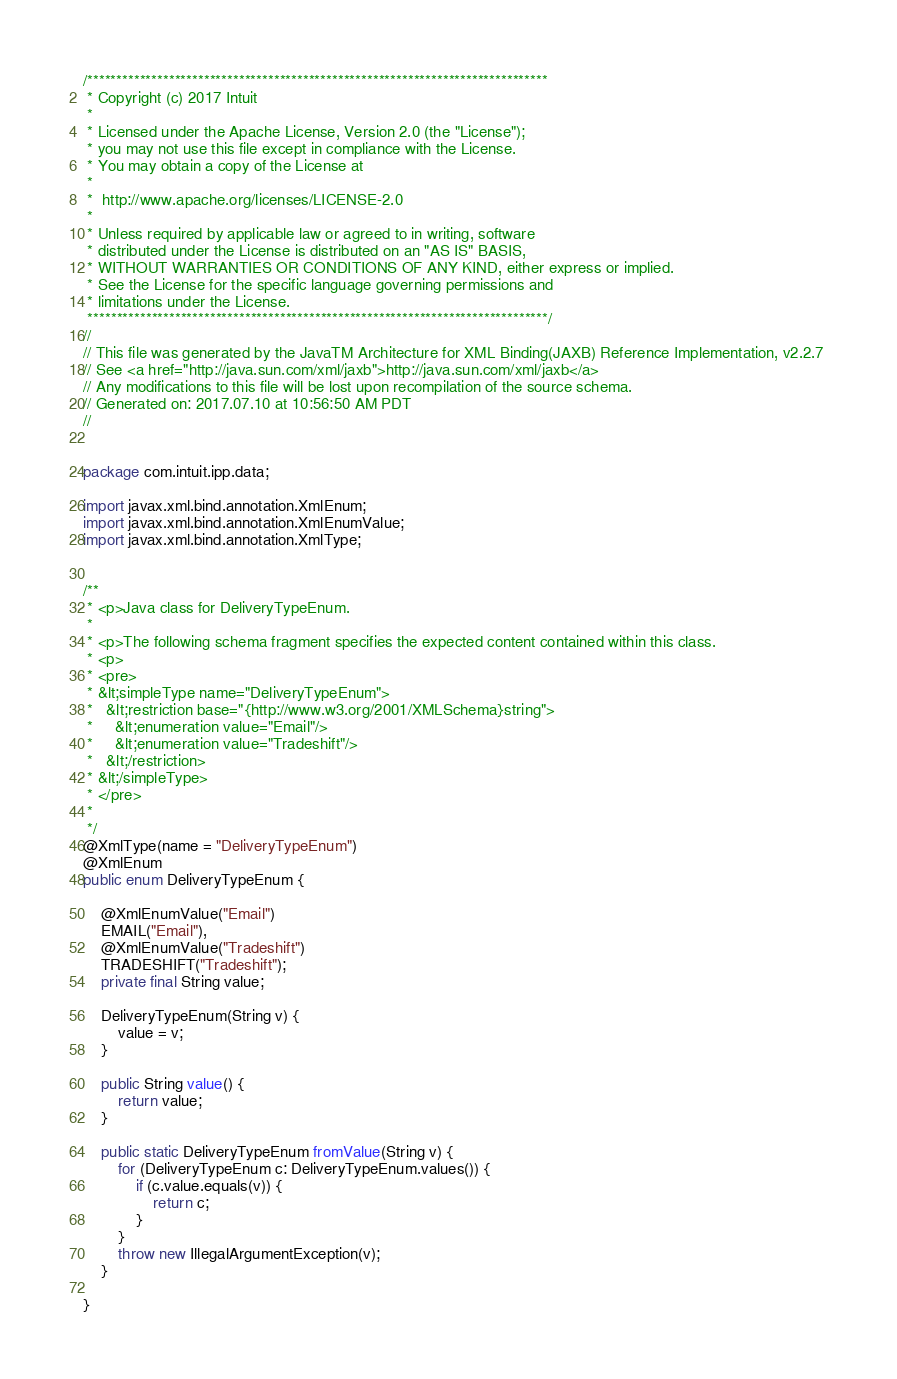Convert code to text. <code><loc_0><loc_0><loc_500><loc_500><_Java_>/*******************************************************************************
 * Copyright (c) 2017 Intuit
 *
 * Licensed under the Apache License, Version 2.0 (the "License");
 * you may not use this file except in compliance with the License.
 * You may obtain a copy of the License at
 *
 *  http://www.apache.org/licenses/LICENSE-2.0
 *
 * Unless required by applicable law or agreed to in writing, software
 * distributed under the License is distributed on an "AS IS" BASIS,
 * WITHOUT WARRANTIES OR CONDITIONS OF ANY KIND, either express or implied.
 * See the License for the specific language governing permissions and
 * limitations under the License.
 *******************************************************************************/
//
// This file was generated by the JavaTM Architecture for XML Binding(JAXB) Reference Implementation, v2.2.7 
// See <a href="http://java.sun.com/xml/jaxb">http://java.sun.com/xml/jaxb</a> 
// Any modifications to this file will be lost upon recompilation of the source schema. 
// Generated on: 2017.07.10 at 10:56:50 AM PDT 
//


package com.intuit.ipp.data;

import javax.xml.bind.annotation.XmlEnum;
import javax.xml.bind.annotation.XmlEnumValue;
import javax.xml.bind.annotation.XmlType;


/**
 * <p>Java class for DeliveryTypeEnum.
 * 
 * <p>The following schema fragment specifies the expected content contained within this class.
 * <p>
 * <pre>
 * &lt;simpleType name="DeliveryTypeEnum">
 *   &lt;restriction base="{http://www.w3.org/2001/XMLSchema}string">
 *     &lt;enumeration value="Email"/>
 *     &lt;enumeration value="Tradeshift"/>
 *   &lt;/restriction>
 * &lt;/simpleType>
 * </pre>
 * 
 */
@XmlType(name = "DeliveryTypeEnum")
@XmlEnum
public enum DeliveryTypeEnum {

    @XmlEnumValue("Email")
    EMAIL("Email"),
    @XmlEnumValue("Tradeshift")
    TRADESHIFT("Tradeshift");
    private final String value;

    DeliveryTypeEnum(String v) {
        value = v;
    }

    public String value() {
        return value;
    }

    public static DeliveryTypeEnum fromValue(String v) {
        for (DeliveryTypeEnum c: DeliveryTypeEnum.values()) {
            if (c.value.equals(v)) {
                return c;
            }
        }
        throw new IllegalArgumentException(v);
    }

}
</code> 